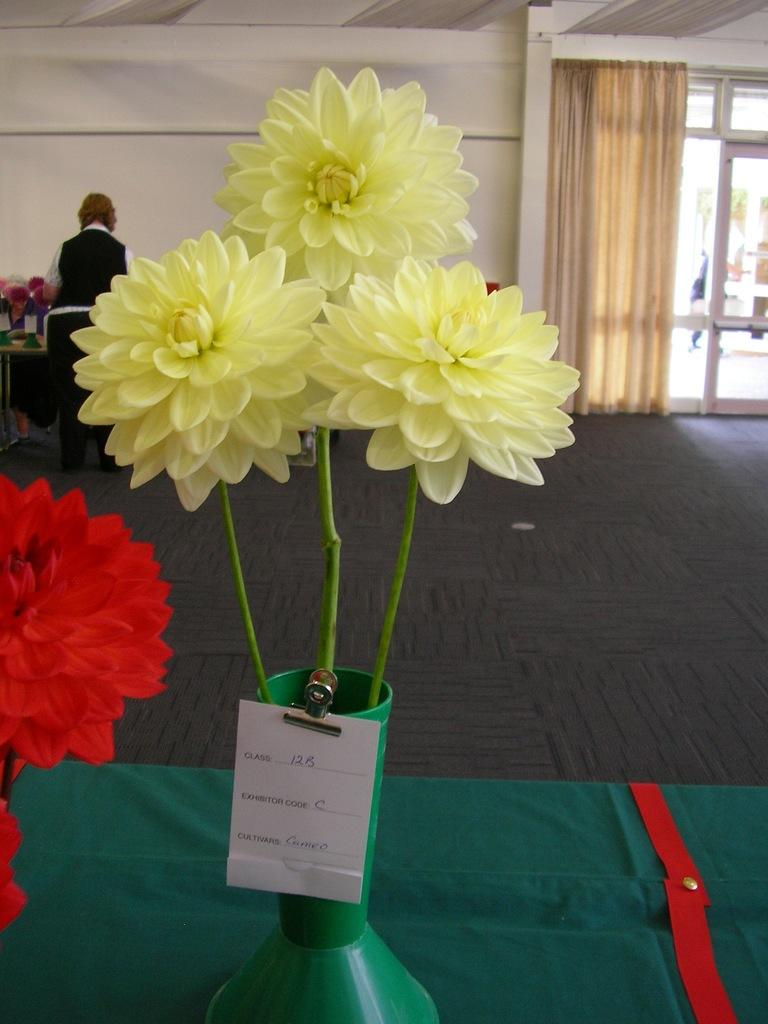What objects are on the table in the image? There are flower vases with name boards on the table. Can you describe the person in the background? There is a person standing in the background, but no specific details about their appearance or actions are provided. What can be seen near the window in the background? There are curtains near a window in the background. What is visible on the wall in the background? There is a wall visible in the background, but no specific details about its appearance or decorations are provided. What type of sheet is being used to reduce friction on the floor in the image? There is no sheet or indication of friction reduction present in the image. 